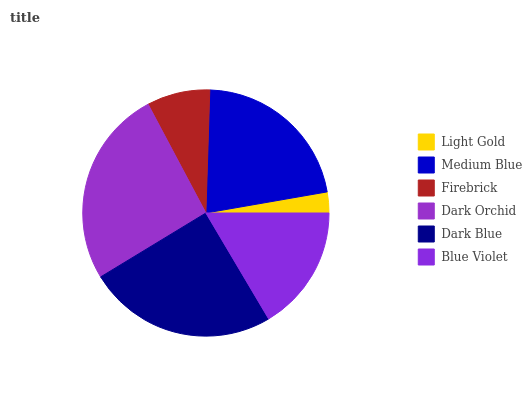Is Light Gold the minimum?
Answer yes or no. Yes. Is Dark Orchid the maximum?
Answer yes or no. Yes. Is Medium Blue the minimum?
Answer yes or no. No. Is Medium Blue the maximum?
Answer yes or no. No. Is Medium Blue greater than Light Gold?
Answer yes or no. Yes. Is Light Gold less than Medium Blue?
Answer yes or no. Yes. Is Light Gold greater than Medium Blue?
Answer yes or no. No. Is Medium Blue less than Light Gold?
Answer yes or no. No. Is Medium Blue the high median?
Answer yes or no. Yes. Is Blue Violet the low median?
Answer yes or no. Yes. Is Dark Blue the high median?
Answer yes or no. No. Is Dark Orchid the low median?
Answer yes or no. No. 